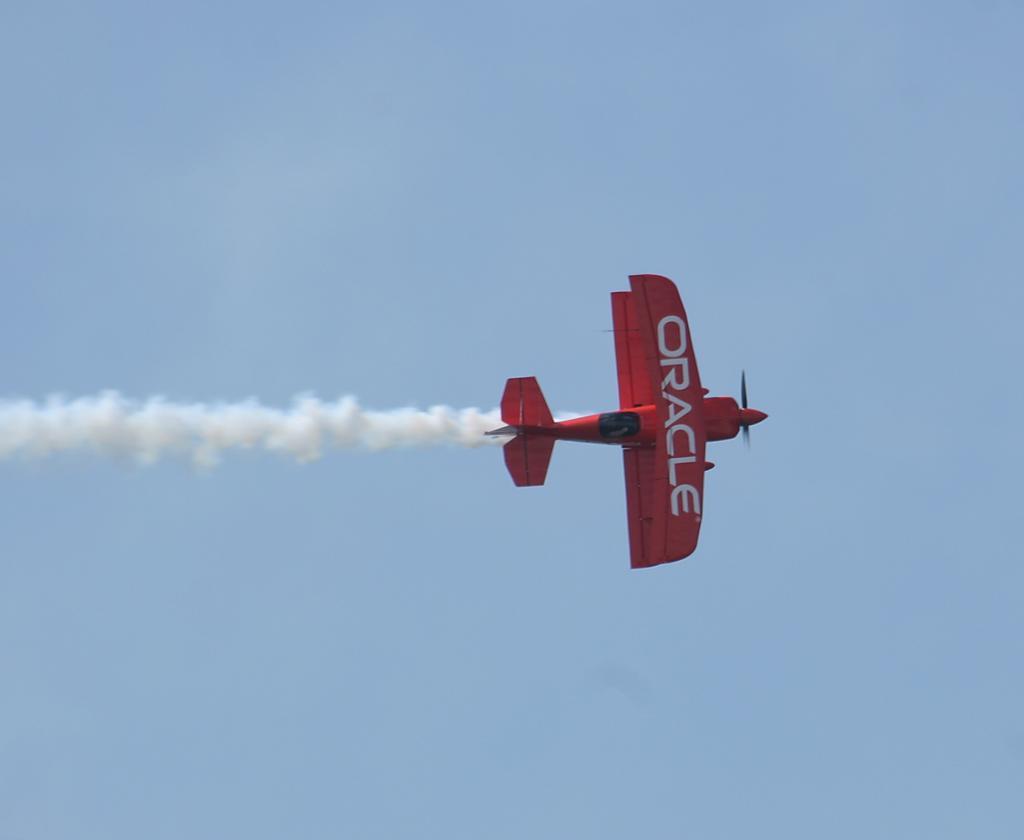How would you summarize this image in a sentence or two? In the center of the image we can see aeroplane. In the background there is a sky. 